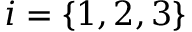<formula> <loc_0><loc_0><loc_500><loc_500>i = \{ 1 , 2 , 3 \}</formula> 